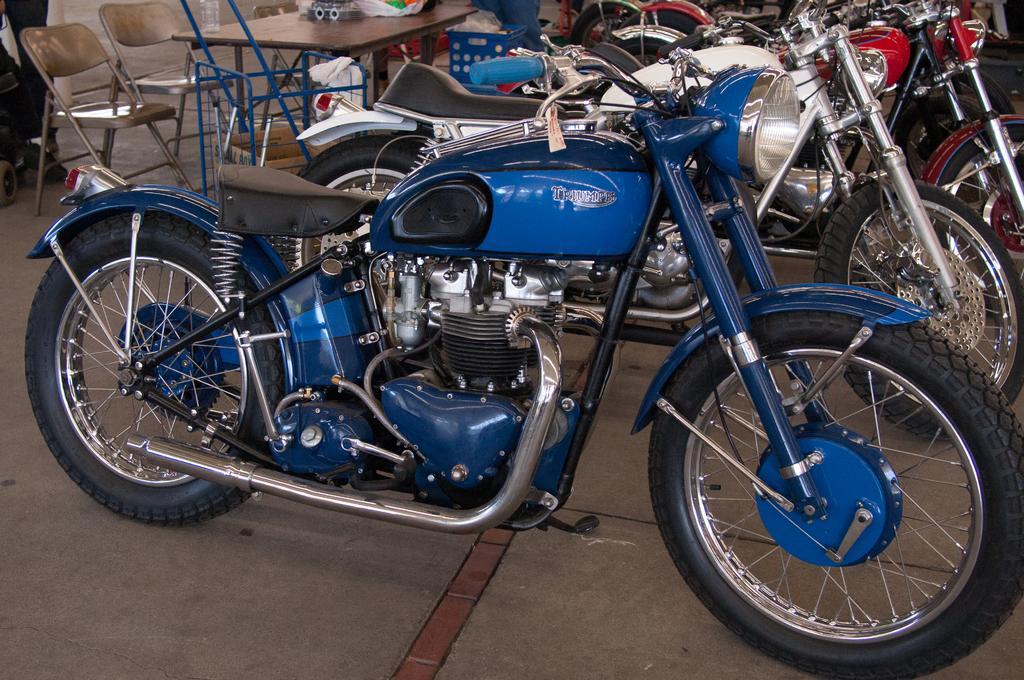Can you describe this image briefly? In this picture there are three boxes, one is blue, another one is white and red. On the table there is a plastic bags. Here there is a two steel chairs. This is a wheel, light, silencer, engine and tank of a bike 